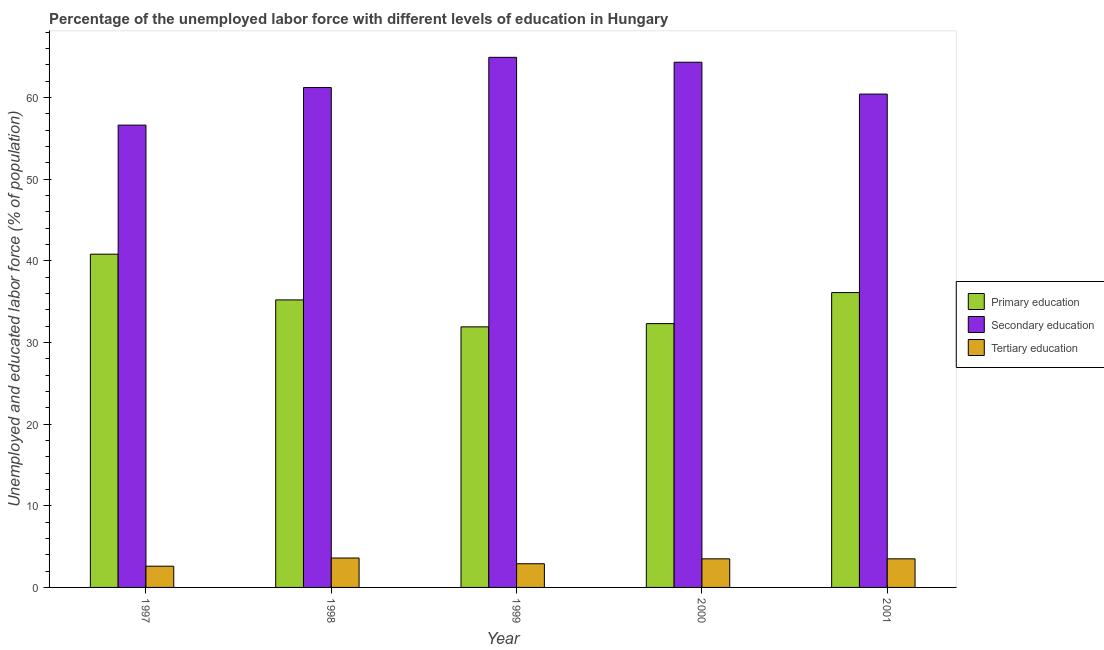Are the number of bars per tick equal to the number of legend labels?
Provide a succinct answer. Yes. Are the number of bars on each tick of the X-axis equal?
Provide a succinct answer. Yes. How many bars are there on the 2nd tick from the right?
Your response must be concise. 3. What is the label of the 4th group of bars from the left?
Ensure brevity in your answer.  2000. What is the percentage of labor force who received secondary education in 1997?
Your answer should be compact. 56.6. Across all years, what is the maximum percentage of labor force who received secondary education?
Keep it short and to the point. 64.9. Across all years, what is the minimum percentage of labor force who received secondary education?
Give a very brief answer. 56.6. What is the total percentage of labor force who received secondary education in the graph?
Provide a short and direct response. 307.4. What is the difference between the percentage of labor force who received primary education in 1998 and that in 1999?
Ensure brevity in your answer.  3.3. What is the difference between the percentage of labor force who received secondary education in 2000 and the percentage of labor force who received primary education in 1997?
Your response must be concise. 7.7. What is the average percentage of labor force who received tertiary education per year?
Keep it short and to the point. 3.22. In how many years, is the percentage of labor force who received primary education greater than 56 %?
Provide a succinct answer. 0. What is the ratio of the percentage of labor force who received primary education in 1997 to that in 2001?
Your answer should be very brief. 1.13. Is the percentage of labor force who received primary education in 1999 less than that in 2001?
Make the answer very short. Yes. Is the difference between the percentage of labor force who received tertiary education in 1999 and 2000 greater than the difference between the percentage of labor force who received secondary education in 1999 and 2000?
Provide a short and direct response. No. What is the difference between the highest and the second highest percentage of labor force who received primary education?
Give a very brief answer. 4.7. What is the difference between the highest and the lowest percentage of labor force who received primary education?
Provide a succinct answer. 8.9. In how many years, is the percentage of labor force who received primary education greater than the average percentage of labor force who received primary education taken over all years?
Offer a terse response. 2. What does the 3rd bar from the left in 1999 represents?
Keep it short and to the point. Tertiary education. What does the 2nd bar from the right in 1998 represents?
Your response must be concise. Secondary education. Is it the case that in every year, the sum of the percentage of labor force who received primary education and percentage of labor force who received secondary education is greater than the percentage of labor force who received tertiary education?
Make the answer very short. Yes. Are all the bars in the graph horizontal?
Offer a terse response. No. How many years are there in the graph?
Ensure brevity in your answer.  5. Are the values on the major ticks of Y-axis written in scientific E-notation?
Your answer should be very brief. No. Does the graph contain any zero values?
Provide a short and direct response. No. How many legend labels are there?
Give a very brief answer. 3. What is the title of the graph?
Offer a very short reply. Percentage of the unemployed labor force with different levels of education in Hungary. What is the label or title of the Y-axis?
Your answer should be compact. Unemployed and educated labor force (% of population). What is the Unemployed and educated labor force (% of population) in Primary education in 1997?
Your answer should be very brief. 40.8. What is the Unemployed and educated labor force (% of population) of Secondary education in 1997?
Your answer should be compact. 56.6. What is the Unemployed and educated labor force (% of population) of Tertiary education in 1997?
Offer a terse response. 2.6. What is the Unemployed and educated labor force (% of population) in Primary education in 1998?
Give a very brief answer. 35.2. What is the Unemployed and educated labor force (% of population) in Secondary education in 1998?
Give a very brief answer. 61.2. What is the Unemployed and educated labor force (% of population) of Tertiary education in 1998?
Make the answer very short. 3.6. What is the Unemployed and educated labor force (% of population) in Primary education in 1999?
Your response must be concise. 31.9. What is the Unemployed and educated labor force (% of population) in Secondary education in 1999?
Your answer should be compact. 64.9. What is the Unemployed and educated labor force (% of population) in Tertiary education in 1999?
Keep it short and to the point. 2.9. What is the Unemployed and educated labor force (% of population) of Primary education in 2000?
Provide a succinct answer. 32.3. What is the Unemployed and educated labor force (% of population) of Secondary education in 2000?
Offer a terse response. 64.3. What is the Unemployed and educated labor force (% of population) in Tertiary education in 2000?
Your answer should be very brief. 3.5. What is the Unemployed and educated labor force (% of population) in Primary education in 2001?
Your response must be concise. 36.1. What is the Unemployed and educated labor force (% of population) of Secondary education in 2001?
Your response must be concise. 60.4. Across all years, what is the maximum Unemployed and educated labor force (% of population) of Primary education?
Keep it short and to the point. 40.8. Across all years, what is the maximum Unemployed and educated labor force (% of population) of Secondary education?
Your answer should be compact. 64.9. Across all years, what is the maximum Unemployed and educated labor force (% of population) of Tertiary education?
Offer a terse response. 3.6. Across all years, what is the minimum Unemployed and educated labor force (% of population) of Primary education?
Your response must be concise. 31.9. Across all years, what is the minimum Unemployed and educated labor force (% of population) of Secondary education?
Provide a succinct answer. 56.6. Across all years, what is the minimum Unemployed and educated labor force (% of population) of Tertiary education?
Give a very brief answer. 2.6. What is the total Unemployed and educated labor force (% of population) of Primary education in the graph?
Provide a succinct answer. 176.3. What is the total Unemployed and educated labor force (% of population) in Secondary education in the graph?
Give a very brief answer. 307.4. What is the difference between the Unemployed and educated labor force (% of population) of Secondary education in 1997 and that in 1998?
Your answer should be very brief. -4.6. What is the difference between the Unemployed and educated labor force (% of population) in Primary education in 1997 and that in 1999?
Provide a succinct answer. 8.9. What is the difference between the Unemployed and educated labor force (% of population) in Secondary education in 1997 and that in 1999?
Your answer should be compact. -8.3. What is the difference between the Unemployed and educated labor force (% of population) in Primary education in 1997 and that in 2000?
Your answer should be compact. 8.5. What is the difference between the Unemployed and educated labor force (% of population) in Secondary education in 1997 and that in 2001?
Give a very brief answer. -3.8. What is the difference between the Unemployed and educated labor force (% of population) in Tertiary education in 1997 and that in 2001?
Provide a succinct answer. -0.9. What is the difference between the Unemployed and educated labor force (% of population) of Secondary education in 1998 and that in 1999?
Offer a terse response. -3.7. What is the difference between the Unemployed and educated labor force (% of population) of Primary education in 1998 and that in 2000?
Provide a succinct answer. 2.9. What is the difference between the Unemployed and educated labor force (% of population) of Secondary education in 1998 and that in 2000?
Your response must be concise. -3.1. What is the difference between the Unemployed and educated labor force (% of population) of Tertiary education in 1998 and that in 2001?
Offer a very short reply. 0.1. What is the difference between the Unemployed and educated labor force (% of population) in Secondary education in 1999 and that in 2000?
Your answer should be compact. 0.6. What is the difference between the Unemployed and educated labor force (% of population) in Primary education in 1999 and that in 2001?
Provide a short and direct response. -4.2. What is the difference between the Unemployed and educated labor force (% of population) of Secondary education in 2000 and that in 2001?
Offer a very short reply. 3.9. What is the difference between the Unemployed and educated labor force (% of population) in Tertiary education in 2000 and that in 2001?
Give a very brief answer. 0. What is the difference between the Unemployed and educated labor force (% of population) of Primary education in 1997 and the Unemployed and educated labor force (% of population) of Secondary education in 1998?
Ensure brevity in your answer.  -20.4. What is the difference between the Unemployed and educated labor force (% of population) of Primary education in 1997 and the Unemployed and educated labor force (% of population) of Tertiary education in 1998?
Keep it short and to the point. 37.2. What is the difference between the Unemployed and educated labor force (% of population) of Primary education in 1997 and the Unemployed and educated labor force (% of population) of Secondary education in 1999?
Your answer should be compact. -24.1. What is the difference between the Unemployed and educated labor force (% of population) in Primary education in 1997 and the Unemployed and educated labor force (% of population) in Tertiary education in 1999?
Keep it short and to the point. 37.9. What is the difference between the Unemployed and educated labor force (% of population) of Secondary education in 1997 and the Unemployed and educated labor force (% of population) of Tertiary education in 1999?
Your answer should be very brief. 53.7. What is the difference between the Unemployed and educated labor force (% of population) in Primary education in 1997 and the Unemployed and educated labor force (% of population) in Secondary education in 2000?
Keep it short and to the point. -23.5. What is the difference between the Unemployed and educated labor force (% of population) in Primary education in 1997 and the Unemployed and educated labor force (% of population) in Tertiary education in 2000?
Ensure brevity in your answer.  37.3. What is the difference between the Unemployed and educated labor force (% of population) in Secondary education in 1997 and the Unemployed and educated labor force (% of population) in Tertiary education in 2000?
Make the answer very short. 53.1. What is the difference between the Unemployed and educated labor force (% of population) of Primary education in 1997 and the Unemployed and educated labor force (% of population) of Secondary education in 2001?
Give a very brief answer. -19.6. What is the difference between the Unemployed and educated labor force (% of population) in Primary education in 1997 and the Unemployed and educated labor force (% of population) in Tertiary education in 2001?
Provide a succinct answer. 37.3. What is the difference between the Unemployed and educated labor force (% of population) of Secondary education in 1997 and the Unemployed and educated labor force (% of population) of Tertiary education in 2001?
Give a very brief answer. 53.1. What is the difference between the Unemployed and educated labor force (% of population) in Primary education in 1998 and the Unemployed and educated labor force (% of population) in Secondary education in 1999?
Keep it short and to the point. -29.7. What is the difference between the Unemployed and educated labor force (% of population) of Primary education in 1998 and the Unemployed and educated labor force (% of population) of Tertiary education in 1999?
Offer a very short reply. 32.3. What is the difference between the Unemployed and educated labor force (% of population) of Secondary education in 1998 and the Unemployed and educated labor force (% of population) of Tertiary education in 1999?
Your response must be concise. 58.3. What is the difference between the Unemployed and educated labor force (% of population) of Primary education in 1998 and the Unemployed and educated labor force (% of population) of Secondary education in 2000?
Your answer should be compact. -29.1. What is the difference between the Unemployed and educated labor force (% of population) of Primary education in 1998 and the Unemployed and educated labor force (% of population) of Tertiary education in 2000?
Your answer should be compact. 31.7. What is the difference between the Unemployed and educated labor force (% of population) in Secondary education in 1998 and the Unemployed and educated labor force (% of population) in Tertiary education in 2000?
Give a very brief answer. 57.7. What is the difference between the Unemployed and educated labor force (% of population) of Primary education in 1998 and the Unemployed and educated labor force (% of population) of Secondary education in 2001?
Offer a very short reply. -25.2. What is the difference between the Unemployed and educated labor force (% of population) of Primary education in 1998 and the Unemployed and educated labor force (% of population) of Tertiary education in 2001?
Your answer should be very brief. 31.7. What is the difference between the Unemployed and educated labor force (% of population) in Secondary education in 1998 and the Unemployed and educated labor force (% of population) in Tertiary education in 2001?
Ensure brevity in your answer.  57.7. What is the difference between the Unemployed and educated labor force (% of population) in Primary education in 1999 and the Unemployed and educated labor force (% of population) in Secondary education in 2000?
Your response must be concise. -32.4. What is the difference between the Unemployed and educated labor force (% of population) of Primary education in 1999 and the Unemployed and educated labor force (% of population) of Tertiary education in 2000?
Keep it short and to the point. 28.4. What is the difference between the Unemployed and educated labor force (% of population) of Secondary education in 1999 and the Unemployed and educated labor force (% of population) of Tertiary education in 2000?
Provide a succinct answer. 61.4. What is the difference between the Unemployed and educated labor force (% of population) of Primary education in 1999 and the Unemployed and educated labor force (% of population) of Secondary education in 2001?
Your answer should be compact. -28.5. What is the difference between the Unemployed and educated labor force (% of population) of Primary education in 1999 and the Unemployed and educated labor force (% of population) of Tertiary education in 2001?
Provide a succinct answer. 28.4. What is the difference between the Unemployed and educated labor force (% of population) in Secondary education in 1999 and the Unemployed and educated labor force (% of population) in Tertiary education in 2001?
Give a very brief answer. 61.4. What is the difference between the Unemployed and educated labor force (% of population) in Primary education in 2000 and the Unemployed and educated labor force (% of population) in Secondary education in 2001?
Make the answer very short. -28.1. What is the difference between the Unemployed and educated labor force (% of population) of Primary education in 2000 and the Unemployed and educated labor force (% of population) of Tertiary education in 2001?
Make the answer very short. 28.8. What is the difference between the Unemployed and educated labor force (% of population) in Secondary education in 2000 and the Unemployed and educated labor force (% of population) in Tertiary education in 2001?
Provide a succinct answer. 60.8. What is the average Unemployed and educated labor force (% of population) of Primary education per year?
Keep it short and to the point. 35.26. What is the average Unemployed and educated labor force (% of population) in Secondary education per year?
Give a very brief answer. 61.48. What is the average Unemployed and educated labor force (% of population) of Tertiary education per year?
Keep it short and to the point. 3.22. In the year 1997, what is the difference between the Unemployed and educated labor force (% of population) of Primary education and Unemployed and educated labor force (% of population) of Secondary education?
Your answer should be compact. -15.8. In the year 1997, what is the difference between the Unemployed and educated labor force (% of population) in Primary education and Unemployed and educated labor force (% of population) in Tertiary education?
Offer a terse response. 38.2. In the year 1998, what is the difference between the Unemployed and educated labor force (% of population) in Primary education and Unemployed and educated labor force (% of population) in Tertiary education?
Make the answer very short. 31.6. In the year 1998, what is the difference between the Unemployed and educated labor force (% of population) of Secondary education and Unemployed and educated labor force (% of population) of Tertiary education?
Provide a succinct answer. 57.6. In the year 1999, what is the difference between the Unemployed and educated labor force (% of population) of Primary education and Unemployed and educated labor force (% of population) of Secondary education?
Offer a terse response. -33. In the year 2000, what is the difference between the Unemployed and educated labor force (% of population) in Primary education and Unemployed and educated labor force (% of population) in Secondary education?
Make the answer very short. -32. In the year 2000, what is the difference between the Unemployed and educated labor force (% of population) of Primary education and Unemployed and educated labor force (% of population) of Tertiary education?
Your answer should be very brief. 28.8. In the year 2000, what is the difference between the Unemployed and educated labor force (% of population) of Secondary education and Unemployed and educated labor force (% of population) of Tertiary education?
Offer a terse response. 60.8. In the year 2001, what is the difference between the Unemployed and educated labor force (% of population) in Primary education and Unemployed and educated labor force (% of population) in Secondary education?
Provide a succinct answer. -24.3. In the year 2001, what is the difference between the Unemployed and educated labor force (% of population) of Primary education and Unemployed and educated labor force (% of population) of Tertiary education?
Offer a terse response. 32.6. In the year 2001, what is the difference between the Unemployed and educated labor force (% of population) in Secondary education and Unemployed and educated labor force (% of population) in Tertiary education?
Offer a terse response. 56.9. What is the ratio of the Unemployed and educated labor force (% of population) in Primary education in 1997 to that in 1998?
Offer a very short reply. 1.16. What is the ratio of the Unemployed and educated labor force (% of population) in Secondary education in 1997 to that in 1998?
Keep it short and to the point. 0.92. What is the ratio of the Unemployed and educated labor force (% of population) in Tertiary education in 1997 to that in 1998?
Your response must be concise. 0.72. What is the ratio of the Unemployed and educated labor force (% of population) of Primary education in 1997 to that in 1999?
Your response must be concise. 1.28. What is the ratio of the Unemployed and educated labor force (% of population) of Secondary education in 1997 to that in 1999?
Your answer should be very brief. 0.87. What is the ratio of the Unemployed and educated labor force (% of population) in Tertiary education in 1997 to that in 1999?
Offer a terse response. 0.9. What is the ratio of the Unemployed and educated labor force (% of population) in Primary education in 1997 to that in 2000?
Give a very brief answer. 1.26. What is the ratio of the Unemployed and educated labor force (% of population) in Secondary education in 1997 to that in 2000?
Provide a succinct answer. 0.88. What is the ratio of the Unemployed and educated labor force (% of population) in Tertiary education in 1997 to that in 2000?
Provide a short and direct response. 0.74. What is the ratio of the Unemployed and educated labor force (% of population) in Primary education in 1997 to that in 2001?
Ensure brevity in your answer.  1.13. What is the ratio of the Unemployed and educated labor force (% of population) of Secondary education in 1997 to that in 2001?
Offer a terse response. 0.94. What is the ratio of the Unemployed and educated labor force (% of population) in Tertiary education in 1997 to that in 2001?
Give a very brief answer. 0.74. What is the ratio of the Unemployed and educated labor force (% of population) of Primary education in 1998 to that in 1999?
Keep it short and to the point. 1.1. What is the ratio of the Unemployed and educated labor force (% of population) of Secondary education in 1998 to that in 1999?
Your response must be concise. 0.94. What is the ratio of the Unemployed and educated labor force (% of population) of Tertiary education in 1998 to that in 1999?
Provide a succinct answer. 1.24. What is the ratio of the Unemployed and educated labor force (% of population) of Primary education in 1998 to that in 2000?
Your response must be concise. 1.09. What is the ratio of the Unemployed and educated labor force (% of population) in Secondary education in 1998 to that in 2000?
Ensure brevity in your answer.  0.95. What is the ratio of the Unemployed and educated labor force (% of population) in Tertiary education in 1998 to that in 2000?
Give a very brief answer. 1.03. What is the ratio of the Unemployed and educated labor force (% of population) in Primary education in 1998 to that in 2001?
Your answer should be compact. 0.98. What is the ratio of the Unemployed and educated labor force (% of population) in Secondary education in 1998 to that in 2001?
Provide a short and direct response. 1.01. What is the ratio of the Unemployed and educated labor force (% of population) in Tertiary education in 1998 to that in 2001?
Provide a short and direct response. 1.03. What is the ratio of the Unemployed and educated labor force (% of population) of Primary education in 1999 to that in 2000?
Give a very brief answer. 0.99. What is the ratio of the Unemployed and educated labor force (% of population) in Secondary education in 1999 to that in 2000?
Your response must be concise. 1.01. What is the ratio of the Unemployed and educated labor force (% of population) in Tertiary education in 1999 to that in 2000?
Your response must be concise. 0.83. What is the ratio of the Unemployed and educated labor force (% of population) of Primary education in 1999 to that in 2001?
Your response must be concise. 0.88. What is the ratio of the Unemployed and educated labor force (% of population) of Secondary education in 1999 to that in 2001?
Your answer should be compact. 1.07. What is the ratio of the Unemployed and educated labor force (% of population) of Tertiary education in 1999 to that in 2001?
Your answer should be very brief. 0.83. What is the ratio of the Unemployed and educated labor force (% of population) of Primary education in 2000 to that in 2001?
Keep it short and to the point. 0.89. What is the ratio of the Unemployed and educated labor force (% of population) in Secondary education in 2000 to that in 2001?
Make the answer very short. 1.06. What is the ratio of the Unemployed and educated labor force (% of population) in Tertiary education in 2000 to that in 2001?
Your answer should be very brief. 1. What is the difference between the highest and the second highest Unemployed and educated labor force (% of population) in Primary education?
Give a very brief answer. 4.7. What is the difference between the highest and the second highest Unemployed and educated labor force (% of population) in Secondary education?
Provide a short and direct response. 0.6. What is the difference between the highest and the second highest Unemployed and educated labor force (% of population) in Tertiary education?
Give a very brief answer. 0.1. What is the difference between the highest and the lowest Unemployed and educated labor force (% of population) of Primary education?
Provide a short and direct response. 8.9. What is the difference between the highest and the lowest Unemployed and educated labor force (% of population) of Tertiary education?
Offer a very short reply. 1. 